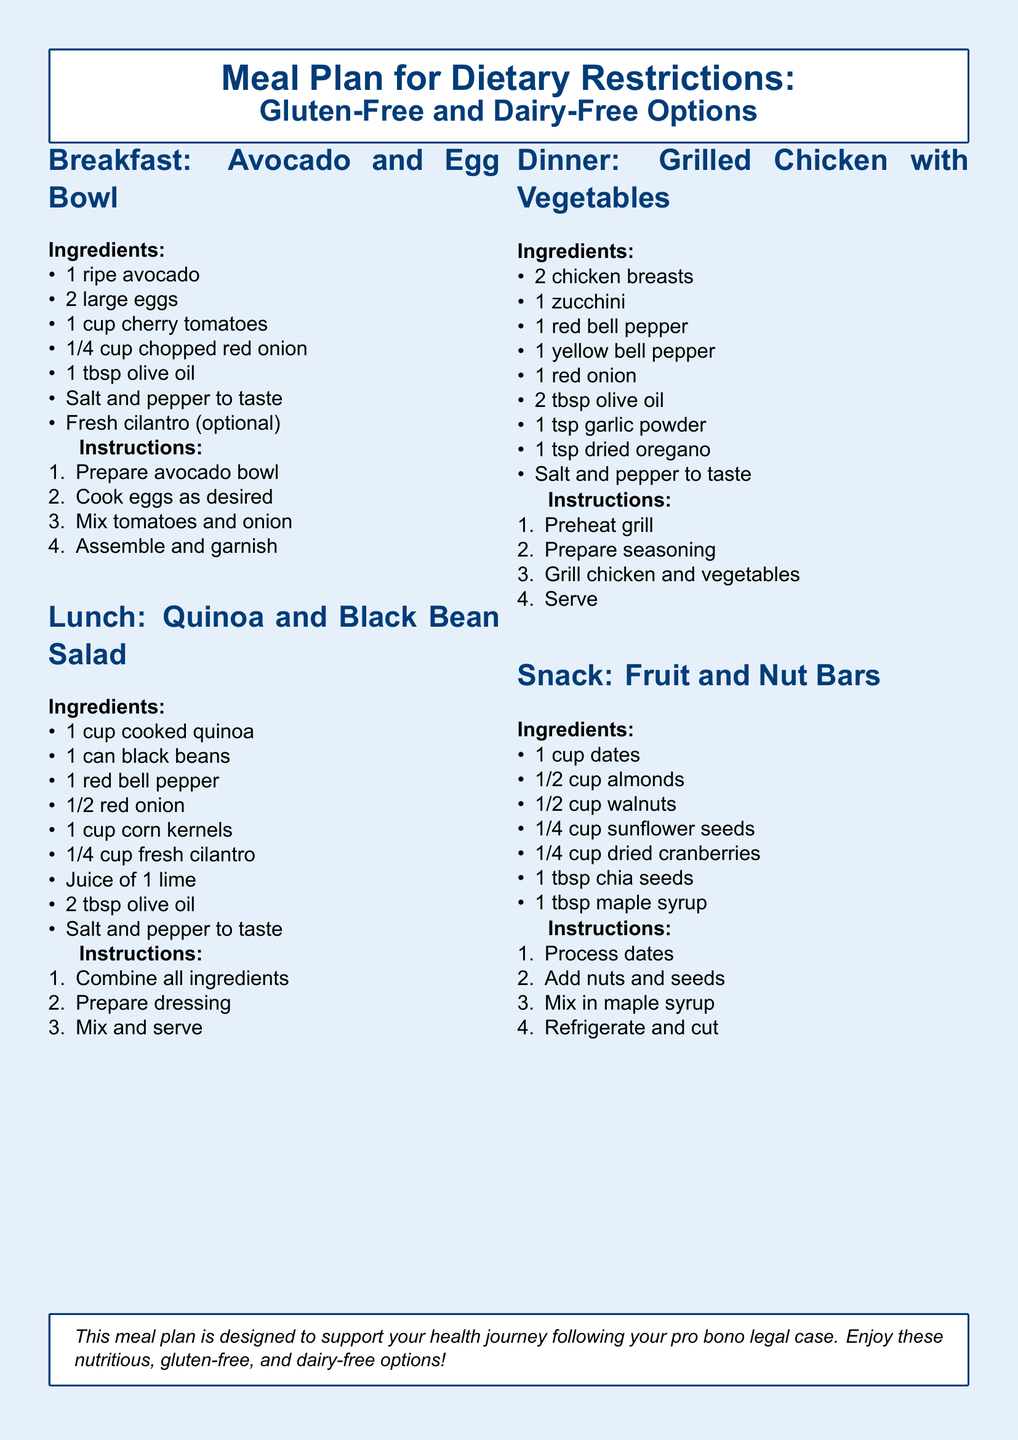What is the title of the meal plan? The title appears at the top of the document and is focused on dietary restrictions, specifically gluten-free and dairy-free options.
Answer: Meal Plan for Dietary Restrictions: Gluten-Free and Dairy-Free Options What is the main protein source in the dinner recipe? The dinner recipe lists chicken breasts as the main protein source, highlighted in the ingredients section.
Answer: Chicken breasts How many tablespoons of olive oil are used in the lunch recipe? The lunch recipe includes the amount of olive oil required in the ingredient list, which is a critical part of the preparation.
Answer: 2 tablespoons What ingredient do the snack bars primarily consist of? The primary ingredient is mentioned at the top of the snack recipe section and reflects the flavor and texture of the bars.
Answer: Dates How many total ingredients are listed for the breakfast recipe? By counting the ingredients listed under the breakfast section, the total amount can be calculated.
Answer: 7 ingredients What cooking method is suggested for the chicken and vegetables? The cooking method is briefly mentioned in the instructions for the dinner section and defines how the meal should be prepared.
Answer: Grill What is added for sweetness in the snack recipe? The snack recipe specifies an ingredient used for sweetness, which contributes to the overall flavor profile of the bars.
Answer: Maple syrup What is the volume measurement for cooked quinoa in the lunch recipe? The amount of cooked quinoa is specified in the lunch ingredients list, which is essential for preparing the recipe.
Answer: 1 cup 